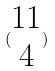Convert formula to latex. <formula><loc_0><loc_0><loc_500><loc_500>( \begin{matrix} 1 1 \\ 4 \end{matrix} )</formula> 